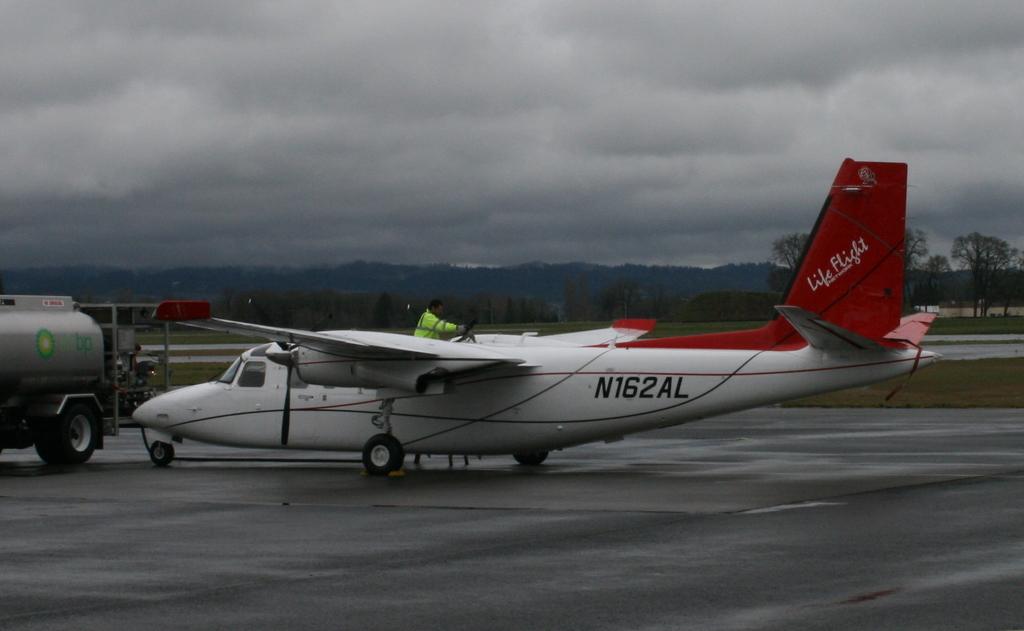What's the hull number on this plane?
Provide a succinct answer. N162al. What gas company owns the truck?
Your answer should be very brief. Bp. 